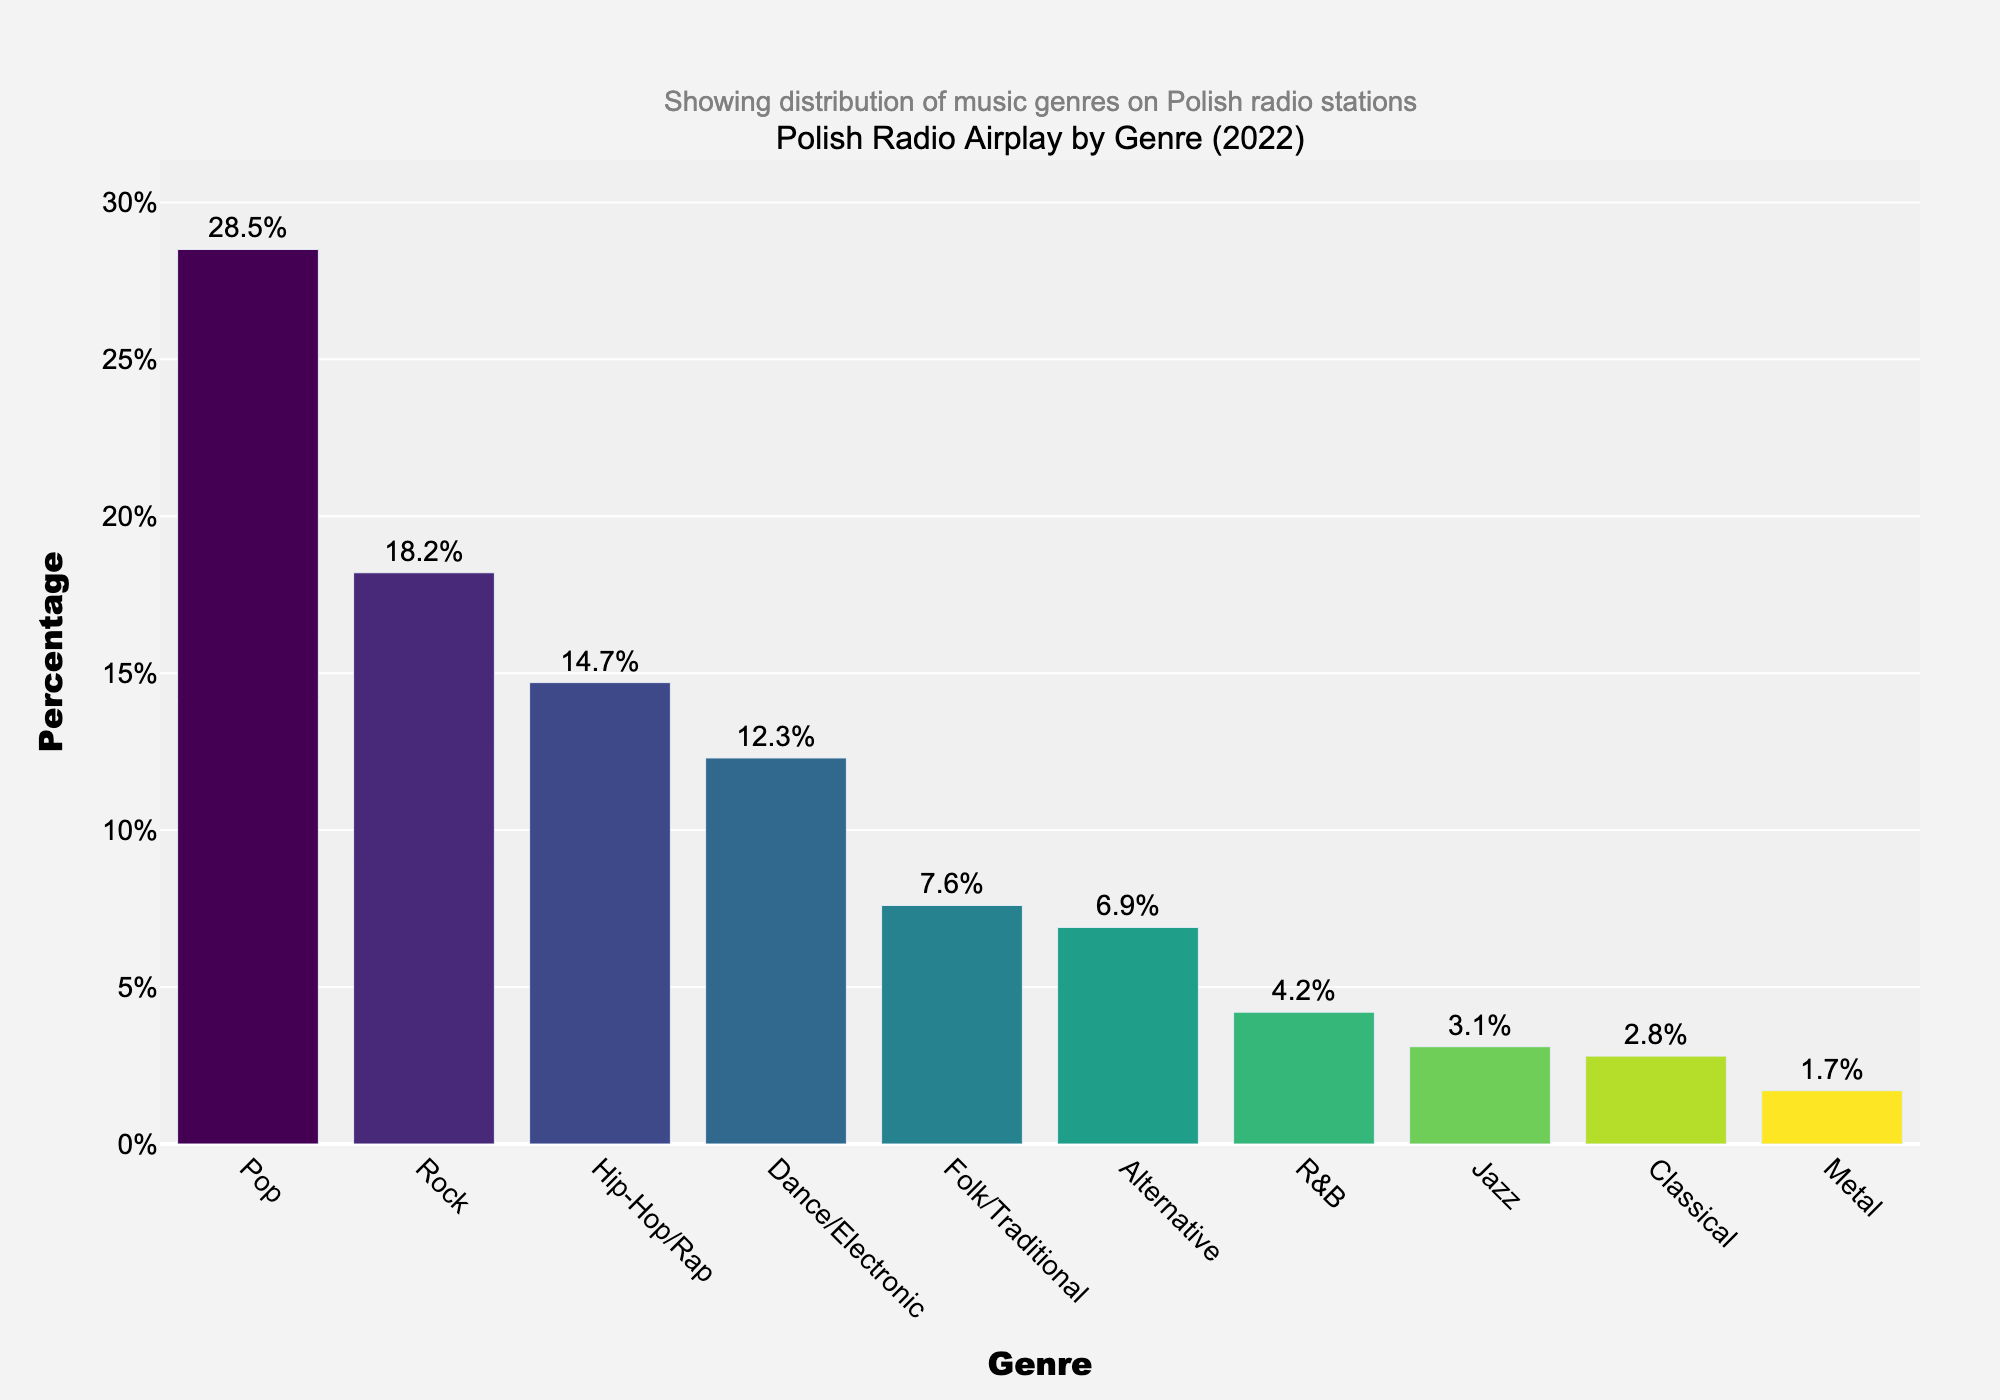Which genre has the highest percentage of radio airplay? To find out which genre has the highest percentage of radio airplay, look at the bar with the greatest height. The label on this bar indicates "Pop".
Answer: Pop What is the combined percentage of airplay for Rock and Hip-Hop/Rap genres? Add the percentages for Rock (18.2%) and Hip-Hop/Rap (14.7%). The combined percentage is 18.2% + 14.7% = 32.9%.
Answer: 32.9% Which genres have less than 5% of the radio airplay? Identify all the bars whose heights correspond to a percentage less than 5%. The genres with less than 5% radio airplay are R&B (4.2%), Jazz (3.1%), Classical (2.8%), and Metal (1.7%).
Answer: R&B, Jazz, Classical, Metal How much more airplay does Dance/Electronic receive compared to Folk/Traditional? Subtract the percentage of Folk/Traditional (7.6%) from the percentage of Dance/Electronic (12.3%). The difference is 12.3% - 7.6% = 4.7%.
Answer: 4.7% What is the average percentage of airplay for the genres listed? Add all the percentages together and divide by the number of genres. The sum is 28.5 + 18.2 + 14.7 + 12.3 + 7.6 + 6.9 + 4.2 + 3.1 + 2.8 + 1.7 = 100.
Answer: 10.0% Which genre has the second lowest percentage of radio airplay? Find the bar with the second shortest height. The genre label next to this bar is "Classical".
Answer: Classical Is the percentage of airplay for Alternative greater than for Folk/Traditional? Compare the percentages for Alternative (6.9%) and Folk/Traditional (7.6%). Since 6.9% is less than 7.6%, Alternative's airplay is not greater.
Answer: No What is the difference in airplay percentage between the highest-percentage genre and the lowest-percentage genre? Subtract the percentage of the lowest genre, Metal (1.7%), from the highest genre, Pop (28.5%). The difference is 28.5% - 1.7% = 26.8%.
Answer: 26.8% 